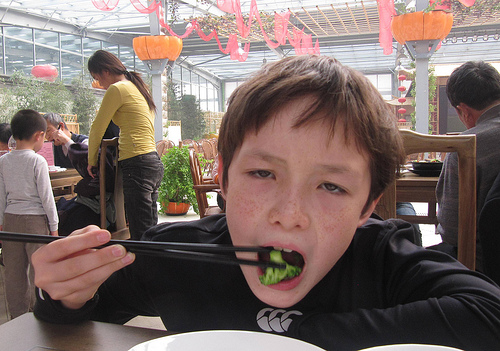<image>
Is the boy on the chair? Yes. Looking at the image, I can see the boy is positioned on top of the chair, with the chair providing support. Is there a boy to the left of the chair? No. The boy is not to the left of the chair. From this viewpoint, they have a different horizontal relationship. 